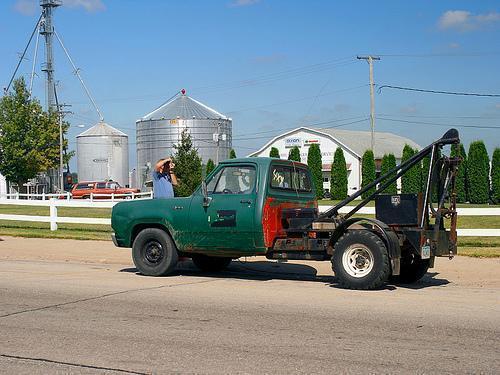What color was this truck originally?
Select the accurate answer and provide justification: `Answer: choice
Rationale: srationale.`
Options: Red, green, yellow, blue. Answer: red.
Rationale: Red was the color of origin because you see it under the green that has been used to repaint over 